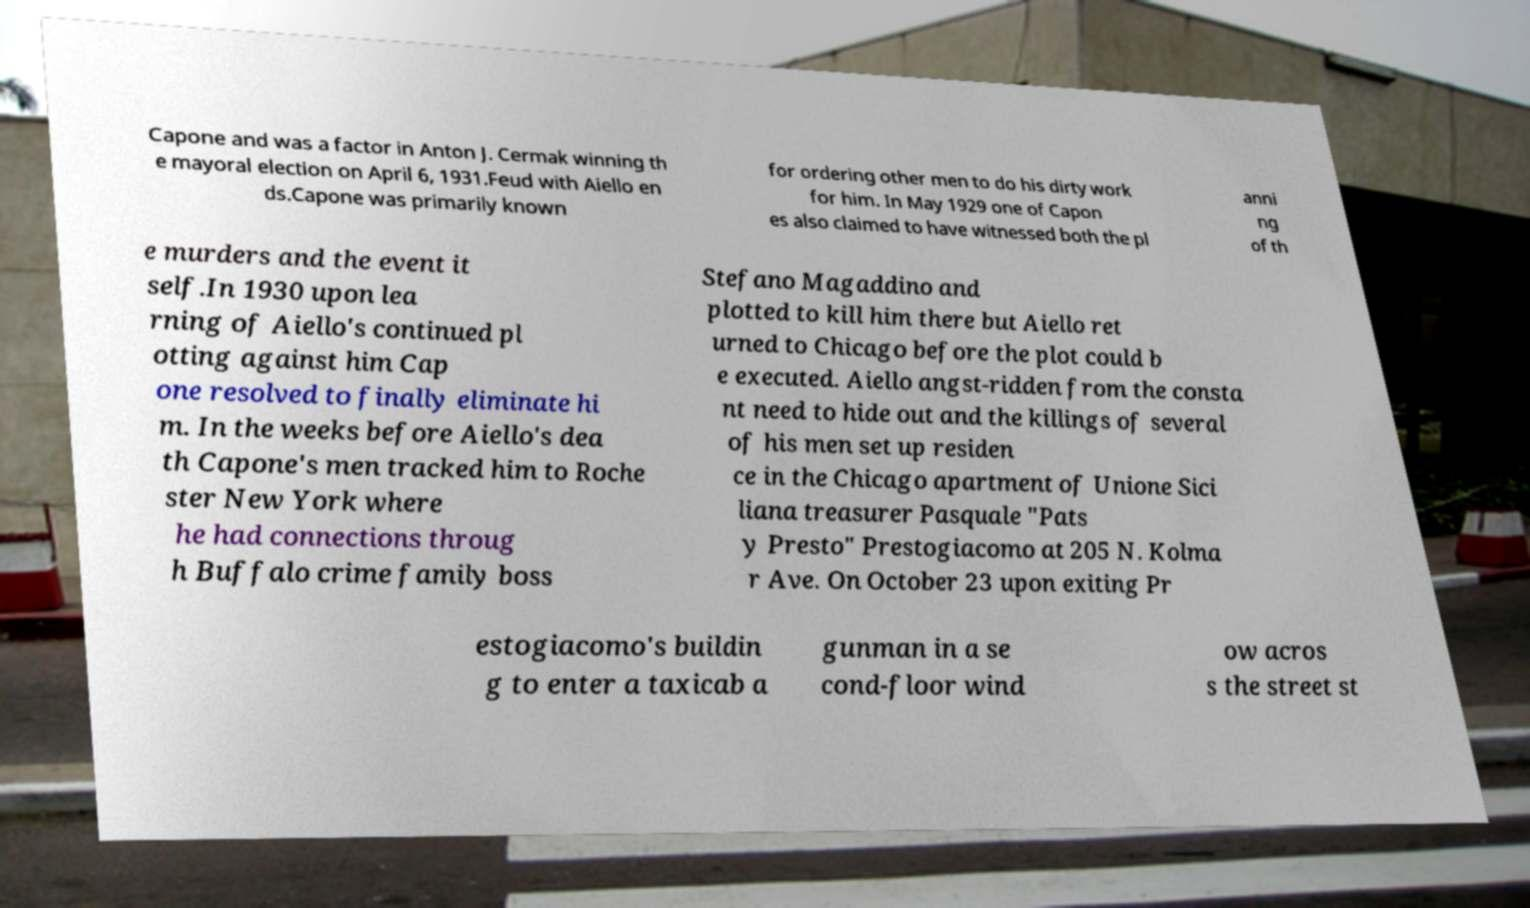For documentation purposes, I need the text within this image transcribed. Could you provide that? Capone and was a factor in Anton J. Cermak winning th e mayoral election on April 6, 1931.Feud with Aiello en ds.Capone was primarily known for ordering other men to do his dirty work for him. In May 1929 one of Capon es also claimed to have witnessed both the pl anni ng of th e murders and the event it self.In 1930 upon lea rning of Aiello's continued pl otting against him Cap one resolved to finally eliminate hi m. In the weeks before Aiello's dea th Capone's men tracked him to Roche ster New York where he had connections throug h Buffalo crime family boss Stefano Magaddino and plotted to kill him there but Aiello ret urned to Chicago before the plot could b e executed. Aiello angst-ridden from the consta nt need to hide out and the killings of several of his men set up residen ce in the Chicago apartment of Unione Sici liana treasurer Pasquale "Pats y Presto" Prestogiacomo at 205 N. Kolma r Ave. On October 23 upon exiting Pr estogiacomo's buildin g to enter a taxicab a gunman in a se cond-floor wind ow acros s the street st 